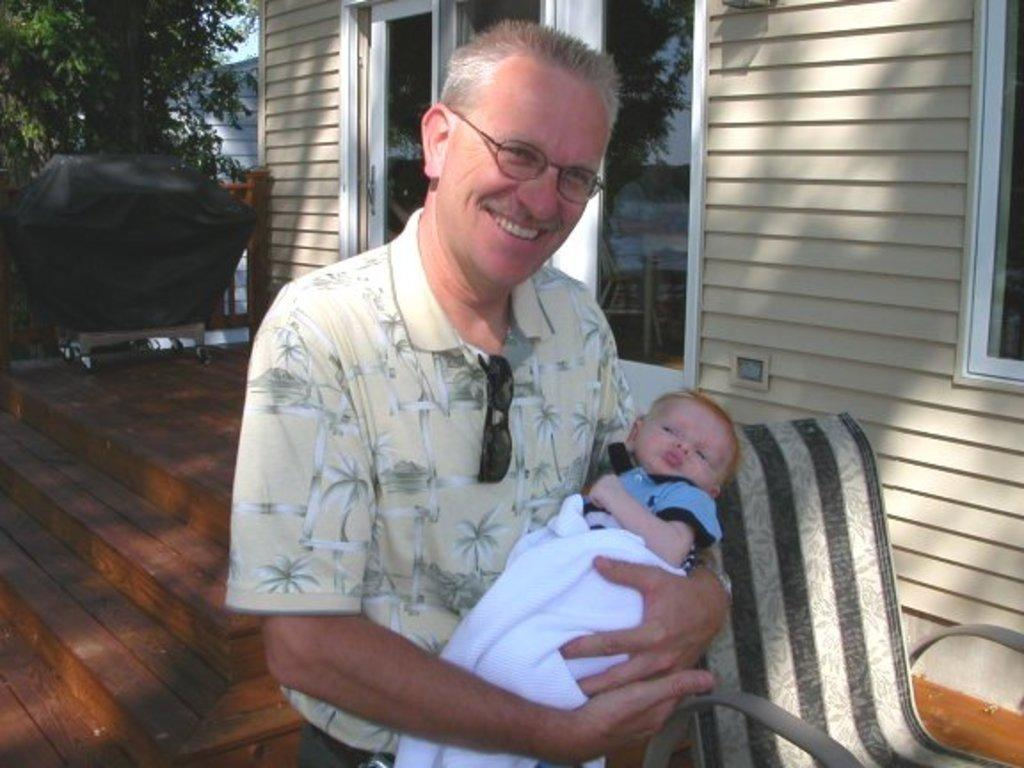What is the man in the image doing? The man is standing in the image and carrying a baby. What object can be seen in the image that is typically used for transporting items? There is a trolley in the image. What type of furniture is present in the image? There is a chair in the image. What type of structure is visible in the image? There is a building with windows in the image. What type of vegetation is present in the image? There is a tree in the image. What part of the natural environment is visible in the image? The sky is visible in the image. What type of property is being played on the chessboard in the image? There is no chessboard present in the image. How many trees are visible in the image? There is only one tree visible in the image. 